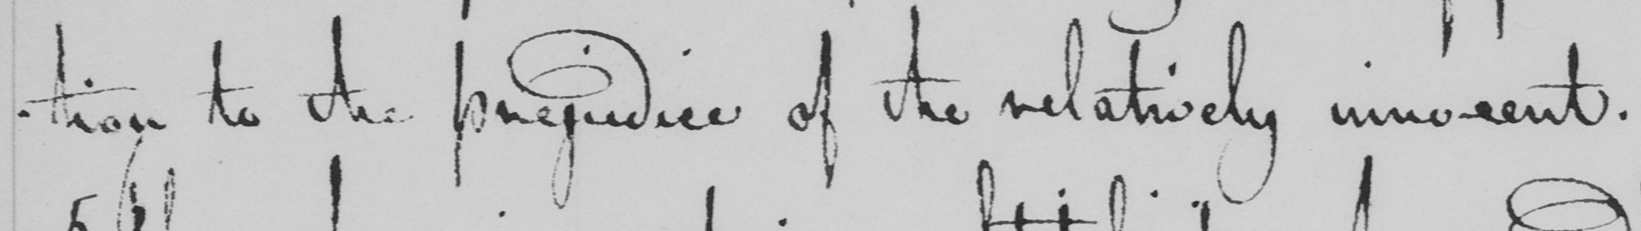Please transcribe the handwritten text in this image. -tion to the prejudice of the relatively innocent . 